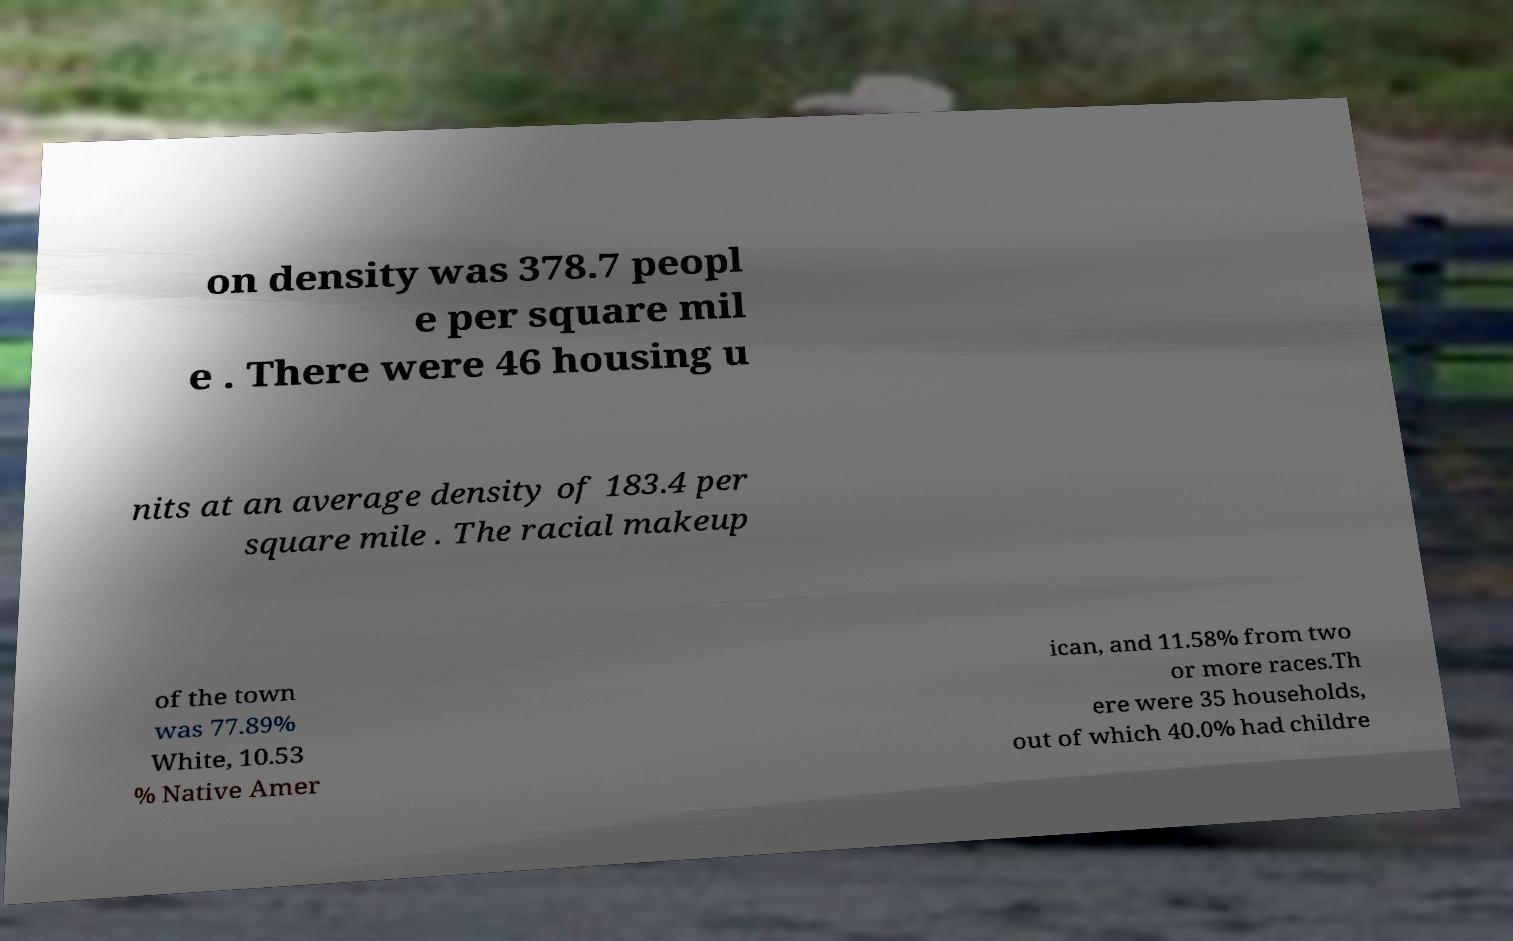Could you assist in decoding the text presented in this image and type it out clearly? on density was 378.7 peopl e per square mil e . There were 46 housing u nits at an average density of 183.4 per square mile . The racial makeup of the town was 77.89% White, 10.53 % Native Amer ican, and 11.58% from two or more races.Th ere were 35 households, out of which 40.0% had childre 